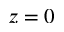<formula> <loc_0><loc_0><loc_500><loc_500>z = 0</formula> 